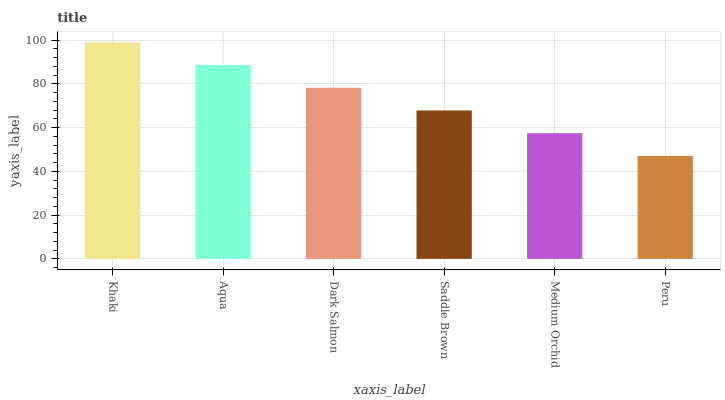Is Peru the minimum?
Answer yes or no. Yes. Is Khaki the maximum?
Answer yes or no. Yes. Is Aqua the minimum?
Answer yes or no. No. Is Aqua the maximum?
Answer yes or no. No. Is Khaki greater than Aqua?
Answer yes or no. Yes. Is Aqua less than Khaki?
Answer yes or no. Yes. Is Aqua greater than Khaki?
Answer yes or no. No. Is Khaki less than Aqua?
Answer yes or no. No. Is Dark Salmon the high median?
Answer yes or no. Yes. Is Saddle Brown the low median?
Answer yes or no. Yes. Is Peru the high median?
Answer yes or no. No. Is Peru the low median?
Answer yes or no. No. 